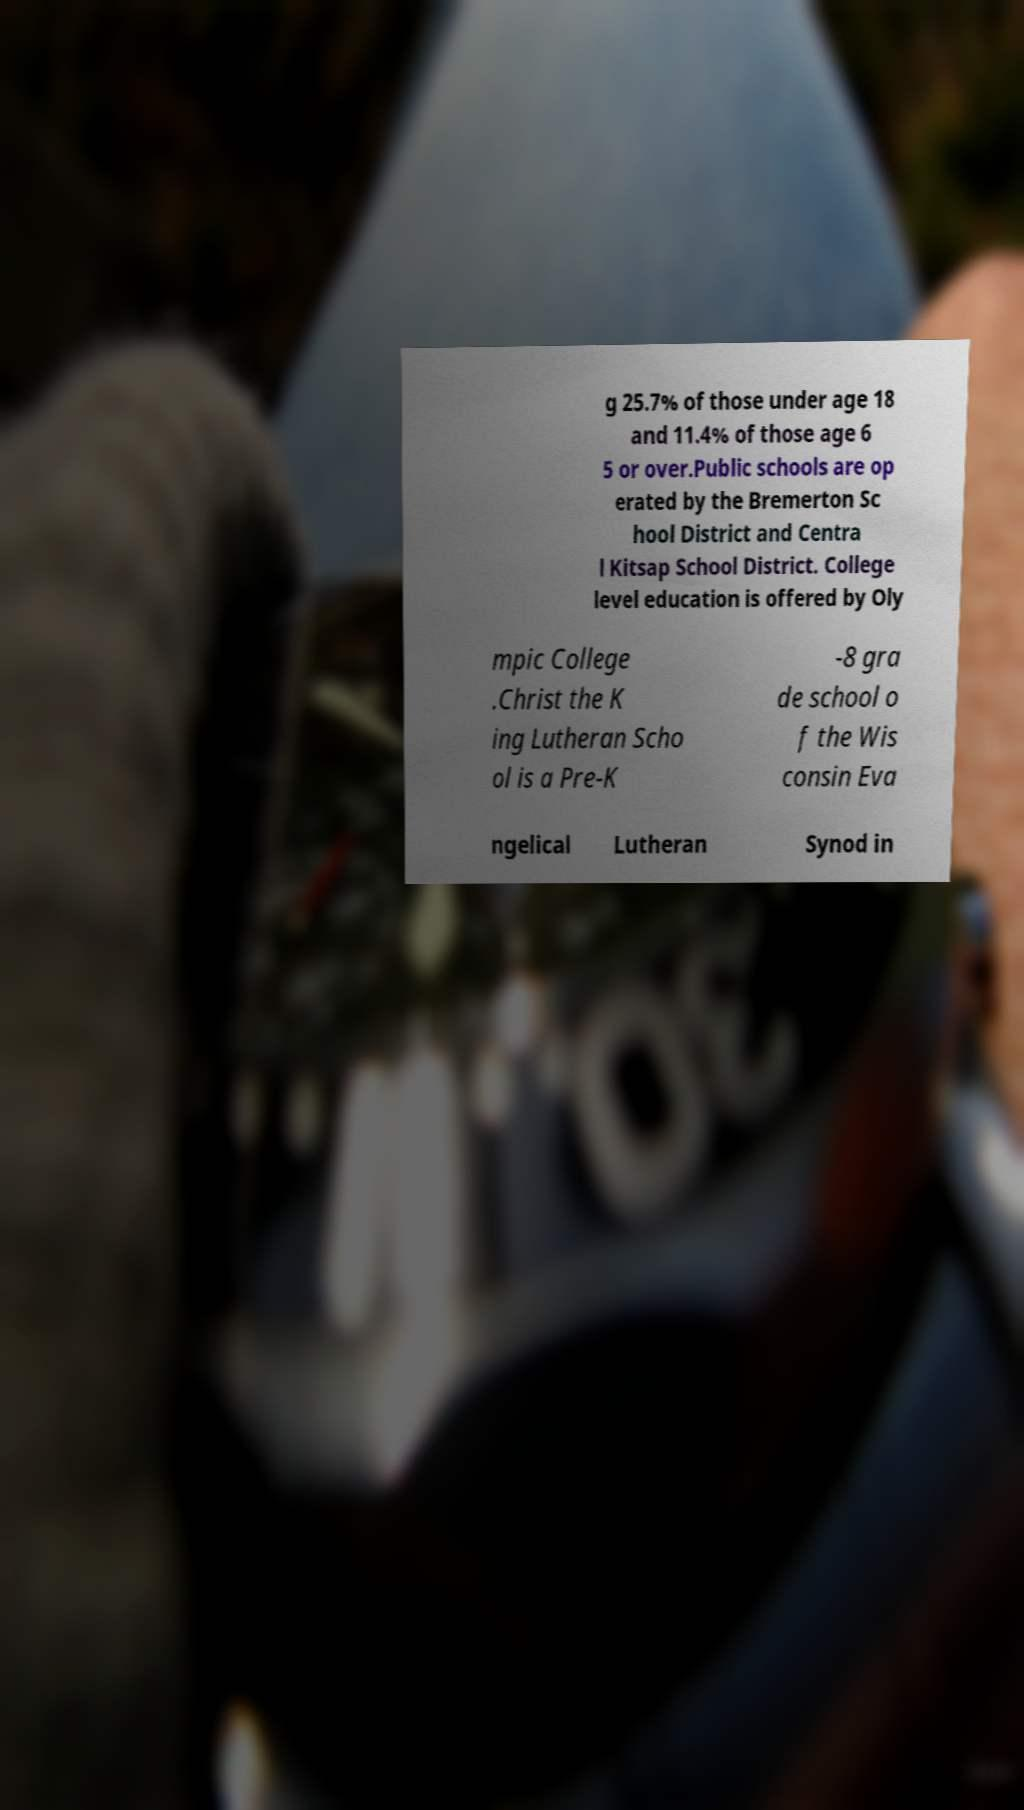What messages or text are displayed in this image? I need them in a readable, typed format. g 25.7% of those under age 18 and 11.4% of those age 6 5 or over.Public schools are op erated by the Bremerton Sc hool District and Centra l Kitsap School District. College level education is offered by Oly mpic College .Christ the K ing Lutheran Scho ol is a Pre-K -8 gra de school o f the Wis consin Eva ngelical Lutheran Synod in 